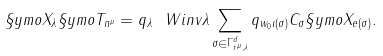Convert formula to latex. <formula><loc_0><loc_0><loc_500><loc_500>\S y m o X _ { \lambda } \S y m o T _ { n ^ { \mu } } = q _ { \lambda } \ W i n v { \lambda } \sum _ { \sigma \in \Gamma ^ { d } _ { t ^ { \mu } , \lambda } } q _ { w _ { 0 } \iota ( \sigma ) } C _ { \sigma } \S y m o X _ { e ( \sigma ) } .</formula> 